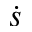Convert formula to latex. <formula><loc_0><loc_0><loc_500><loc_500>\dot { s }</formula> 